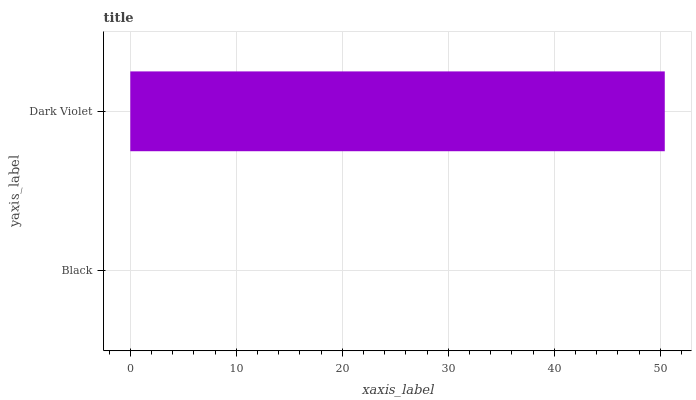Is Black the minimum?
Answer yes or no. Yes. Is Dark Violet the maximum?
Answer yes or no. Yes. Is Dark Violet the minimum?
Answer yes or no. No. Is Dark Violet greater than Black?
Answer yes or no. Yes. Is Black less than Dark Violet?
Answer yes or no. Yes. Is Black greater than Dark Violet?
Answer yes or no. No. Is Dark Violet less than Black?
Answer yes or no. No. Is Dark Violet the high median?
Answer yes or no. Yes. Is Black the low median?
Answer yes or no. Yes. Is Black the high median?
Answer yes or no. No. Is Dark Violet the low median?
Answer yes or no. No. 